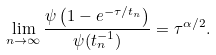Convert formula to latex. <formula><loc_0><loc_0><loc_500><loc_500>\lim _ { n \to \infty } \frac { \psi \left ( 1 - e ^ { - \tau / t _ { n } } \right ) } { \psi ( t _ { n } ^ { - 1 } ) } = \tau ^ { \alpha / 2 } .</formula> 